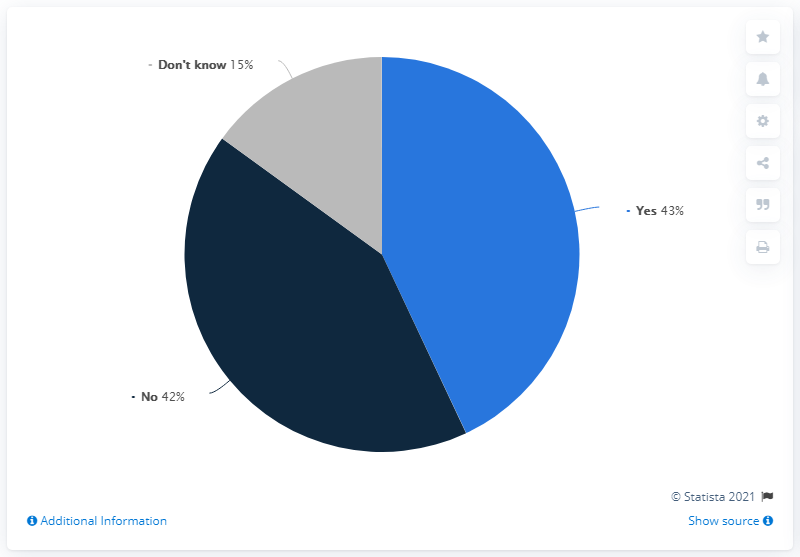Highlight a few significant elements in this photo. I do not know which has the least share. 